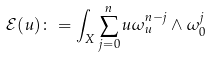<formula> <loc_0><loc_0><loc_500><loc_500>\mathcal { E } ( u ) \colon = \int _ { X } \sum _ { j = 0 } ^ { n } u \omega _ { u } ^ { n - j } \wedge \omega _ { 0 } ^ { j }</formula> 